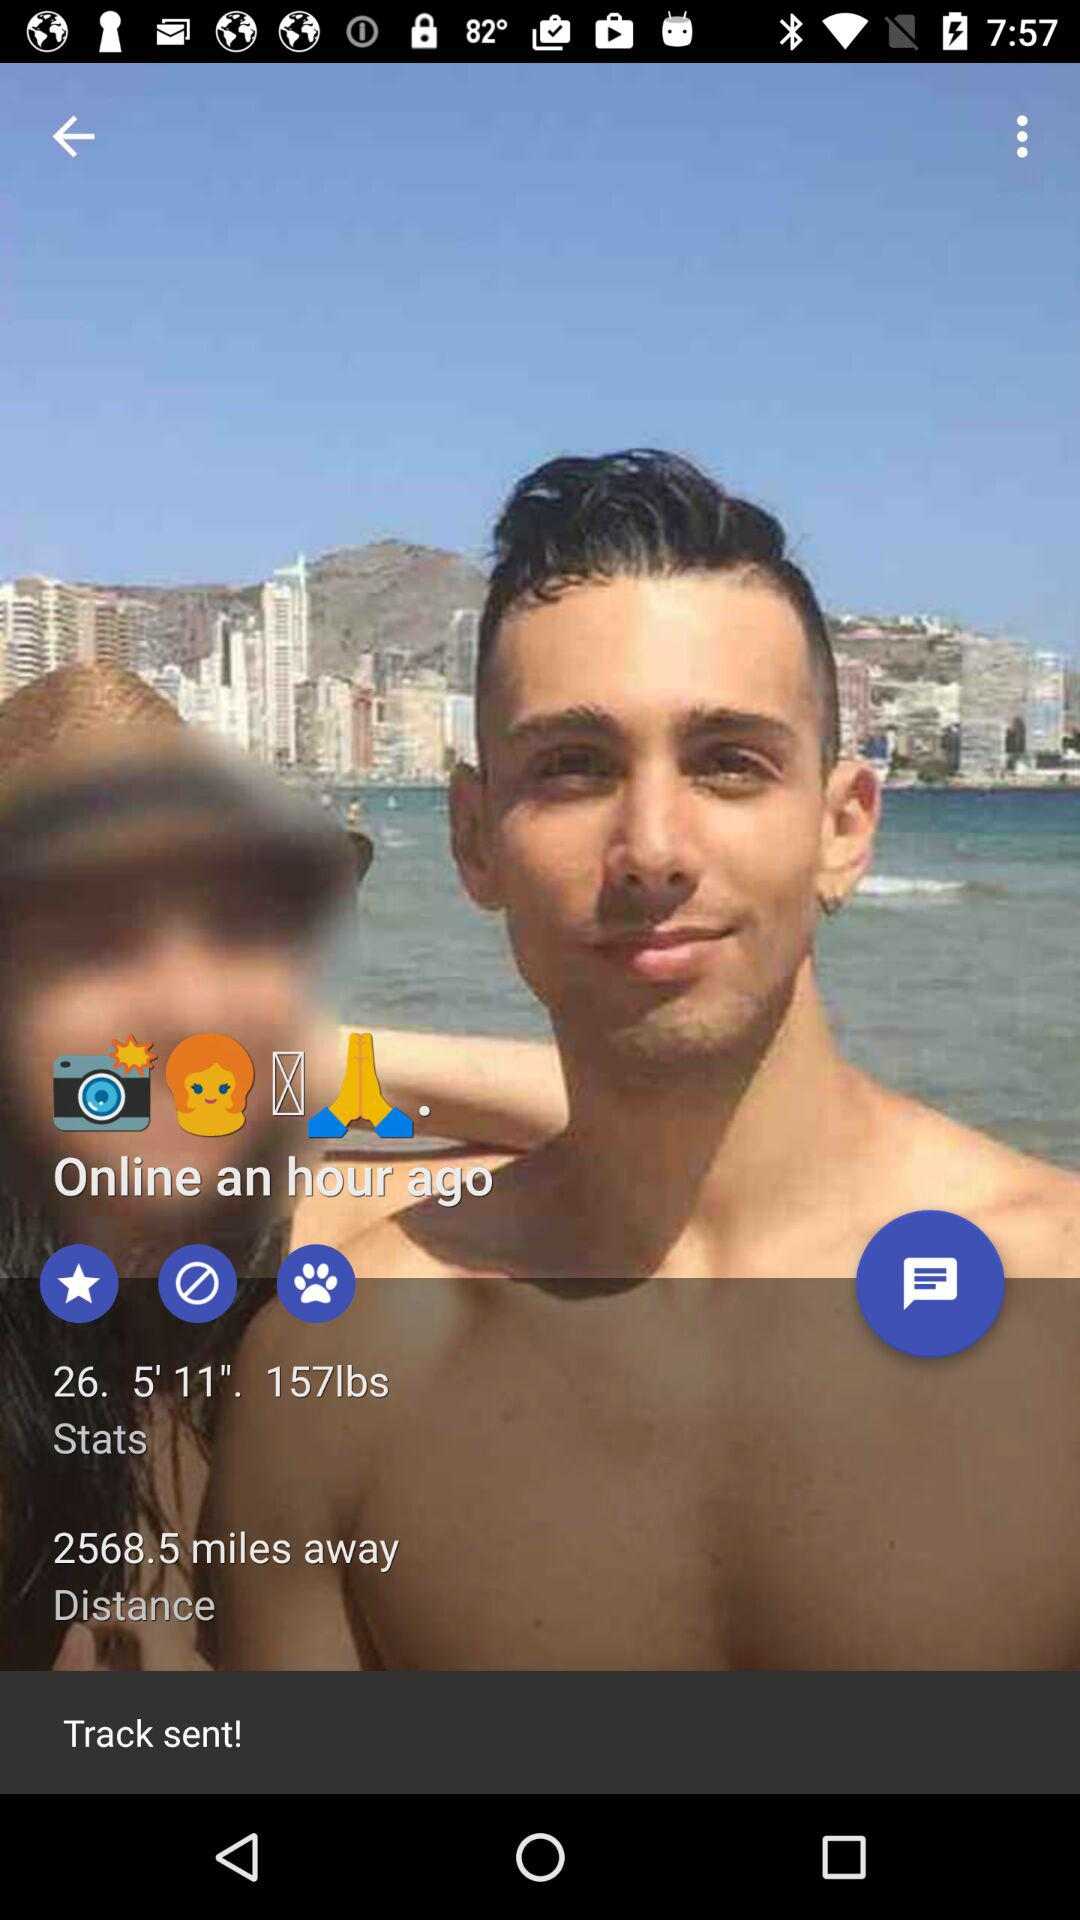What is the age? The age is 26 years. 